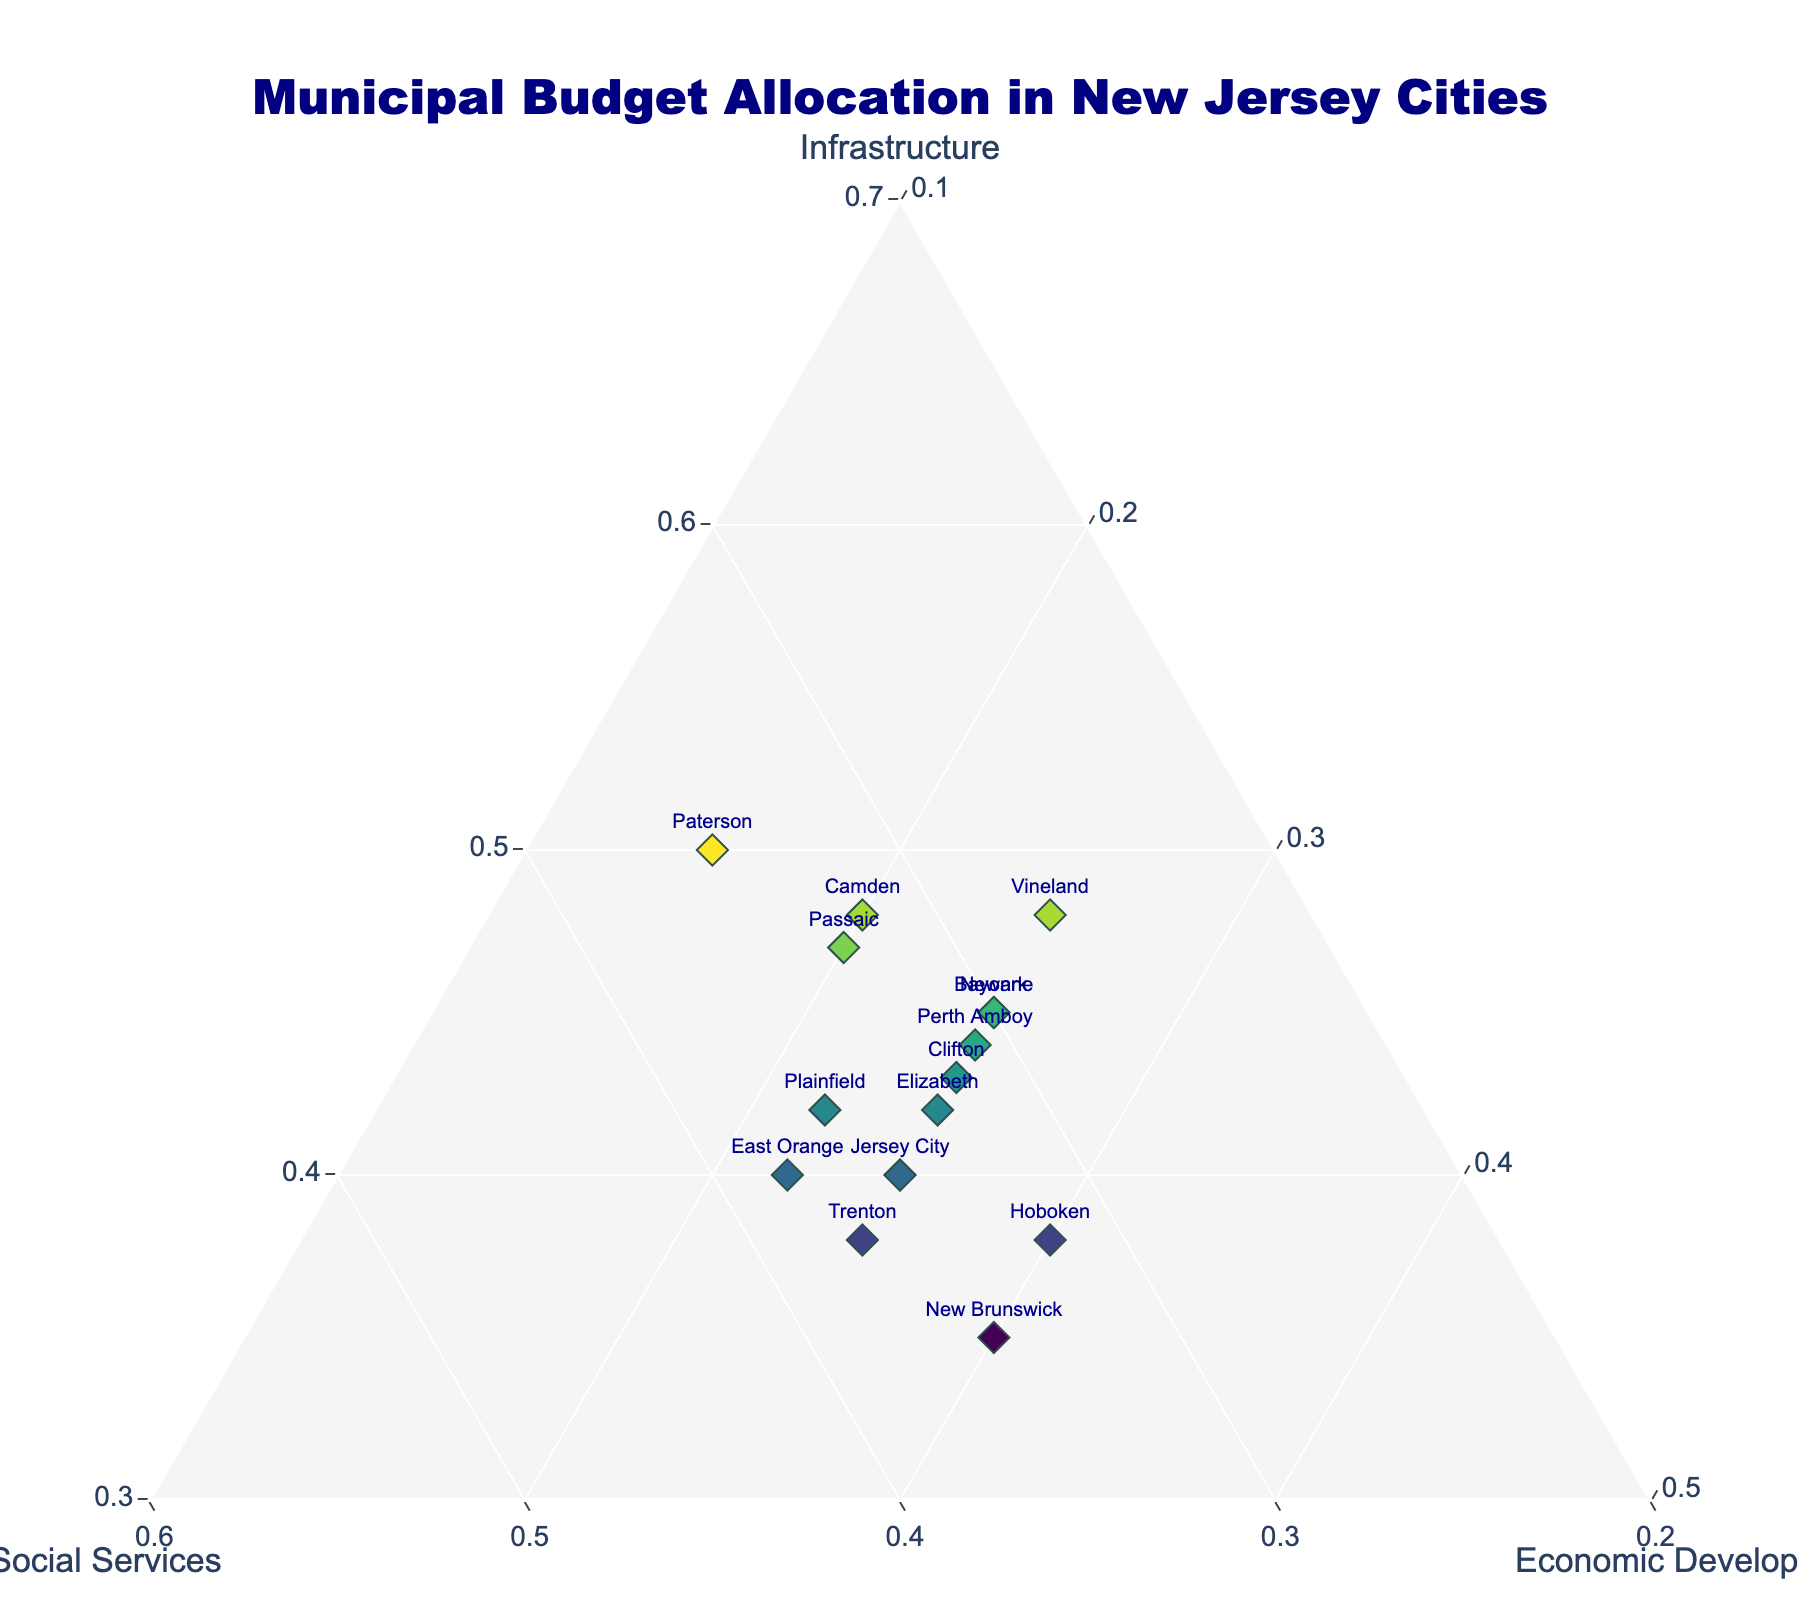What's the title of the figure? The title of the figure is placed prominently at the top and is written in bold, large font.
Answer: Municipal Budget Allocation in New Jersey Cities Which axis represents the allocation to "Social Services"? Ternary plots have three axes: one for each component. By looking at the plot, we can see that the "Social Services" title is aligned with one of these axes.
Answer: The axis labeled "b." Which city allocates the highest percentage to "Economic Development"? By looking at the ternary plot, we can identify which point lies closest to the "Economic Development" axis. The city closest to the "Economic Development" axis has the highest allocation.
Answer: New Brunswick What is the range of percentages allocated to "Infrastructure"? The "Infrastructure" axis shows the allocation values ranging from the minimum to the maximum. By examining this axis, we can find the range.
Answer: 35% to 50% How many cities allocate more than 40% to "Infrastructure"? By examining the ternary plot, we can count the number of points that are located on the upper part of the "Infrastructure" axis, representing more than 40%.
Answer: 10 cities Which city allocates the least to "Social Services"? By mapping each city's point against the "Social Services" axis, we can identify the city that is furthest from this axis (indicating the lowest allocation).
Answer: Vineland Compare the allocations for "Social Services" between "East Orange" and "Plainfield." Which city allocates more? By locating the points for East Orange and Plainfield on the ternary plot and checking their positions relative to the "Social Services" axis, we can compare allocations.
Answer: East Orange allocates more Which cities have an equal allocation for "Economic Development"? By checking the positions of the points on the ternary plot against the "Economic Development" axis, we can identify cities that share the same position.
Answer: Newark, Jersey City, Elizabeth, Trenton, Bayonne, Vineland, and Perth Amboy Calculate the average allocation to "Infrastructure" across all cities. Summing the "Infrastructure" allocations for all cities and dividing by the number of cities provides the average. The values are 45, 40, 50, 42, 38, 48, 43, 47, 40, 45, 48, 35, 44, 38, and 42. The sum is 645. Dividing this by 15 gives 43%.
Answer: 43% 